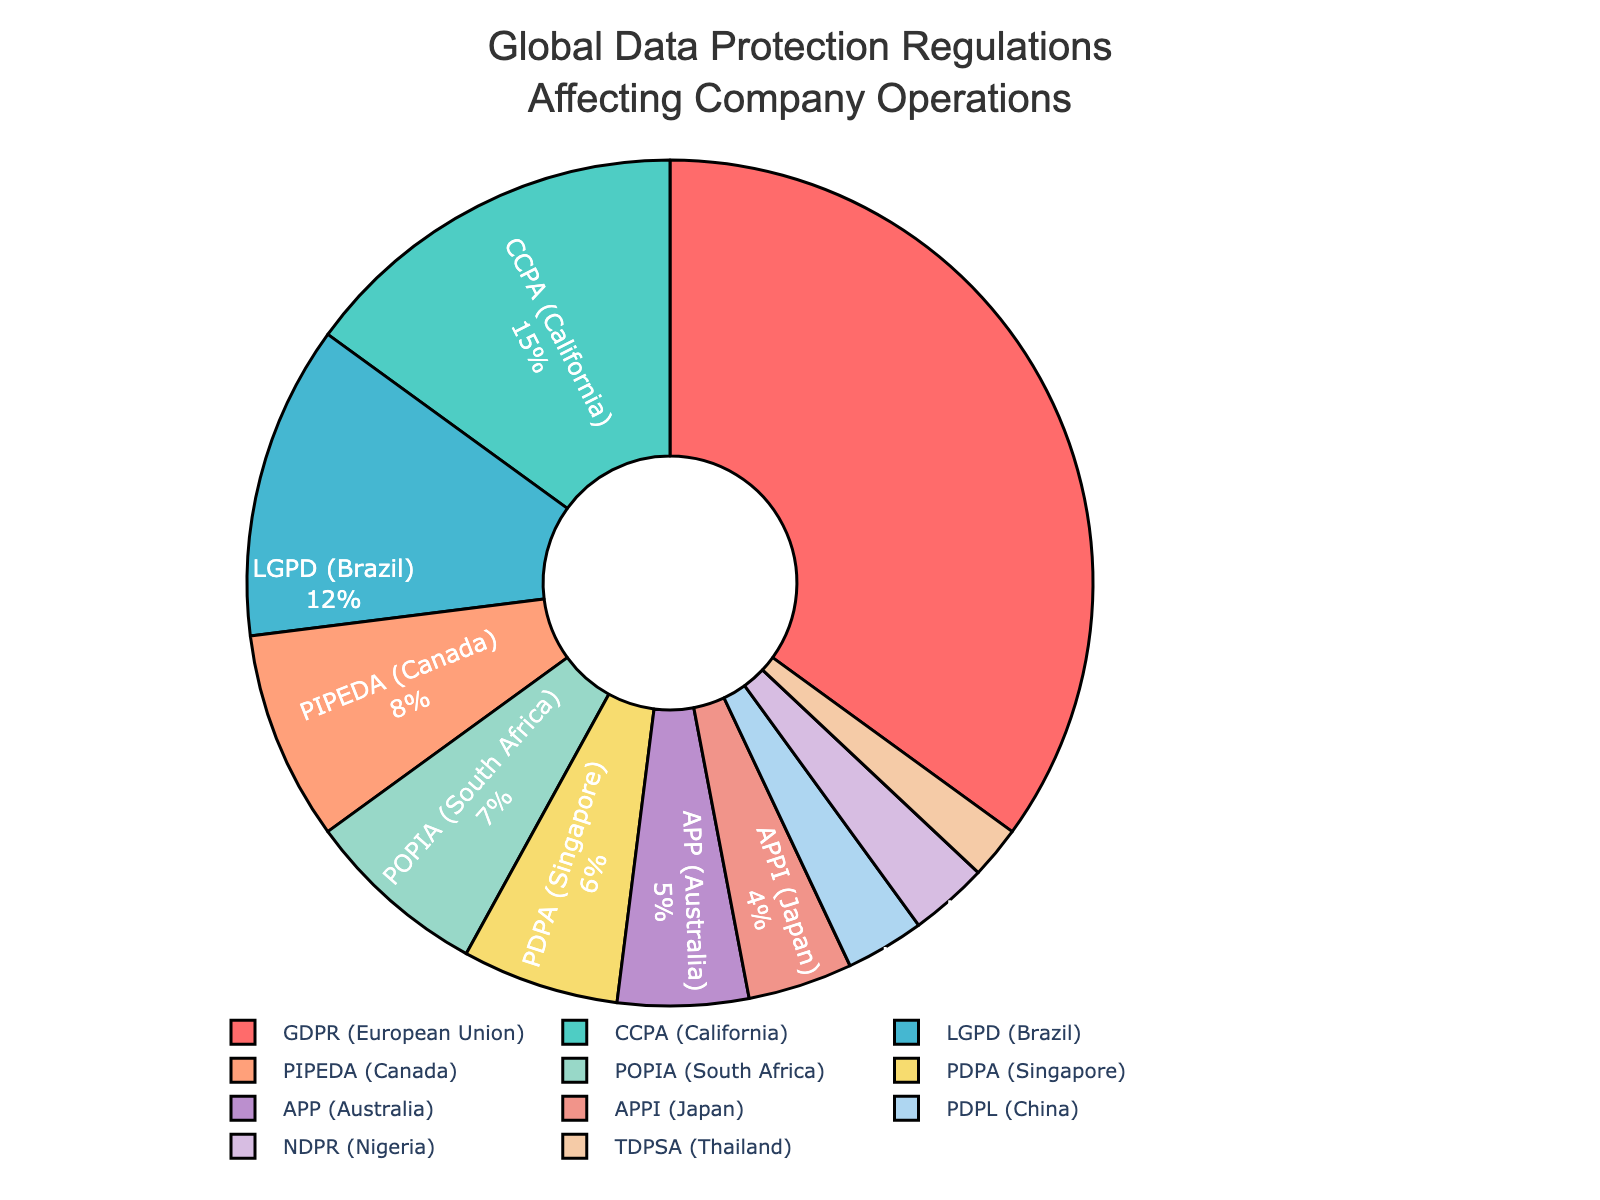What percentage of the global data protection regulations affecting the company's operations is attributed to GDPR? The pie chart shows the breakdown of various global data protection regulations affecting the company's operations, with GDPR accounting for a specific percentage. By looking at the segment for GDPR, we find it is 35%.
Answer: 35% Which regulation has the smallest percentage, and what is that percentage? By examining the smallest segment on the pie chart, we can see that the segment representing TDPSA (Thailand) is the smallest. The percentage for TDPSA is labeled as 2%.
Answer: TDPSA, 2% How does the percentage for CCPA compare to the percentage for PDPL? The pie chart shows the individual percentages for CCPA and PDPL, which are 15% and 3%, respectively. By comparing these, we can see that CCPA (15%) is significantly larger than PDPL (3%).
Answer: CCPA is greater than PDPL What is the combined percentage of LGPD, PIPEDA, and POPIA? To find the combined percentage, we sum the individual percentages for LGPD (12%), PIPEDA (8%), and POPIA (7%). This sum is calculated as 12 + 8 + 7 = 27%.
Answer: 27% Which regulation is shown in the blue color segment, and what percentage does it represent? By observing the pie chart, the blue-colored segment corresponds to CCPA. The percentage for CCPA is labeled as 15%.
Answer: CCPA, 15% How many regulations each have a percentage less than or equal to 5%? We look at the segments representing percentages of 5% or less. The relevant regulations are APP (5%), APPI (4%), PDPL (3%), NDPR (3%), and TDPSA (2%). There are 5 such regulations.
Answer: 5 What is the visual relationship between the two smallest segments in terms of their percentages and colors? The two smallest segments on the pie chart are TDPSA (2%) and NDPR (3%). The colors of these segments are some of the last entries in the color palette used. By their size and order in the legend, TDPSA has a slightly smaller segment than NDPR.
Answer: TDPSA and NDPR; smallest segments What is the total percentage of all regulations from Africa? From the pie chart, the African regulations are POPIA (7%) from South Africa and NDPR (3%) from Nigeria. Adding these gives 7 + 3 = 10%.
Answer: 10% 